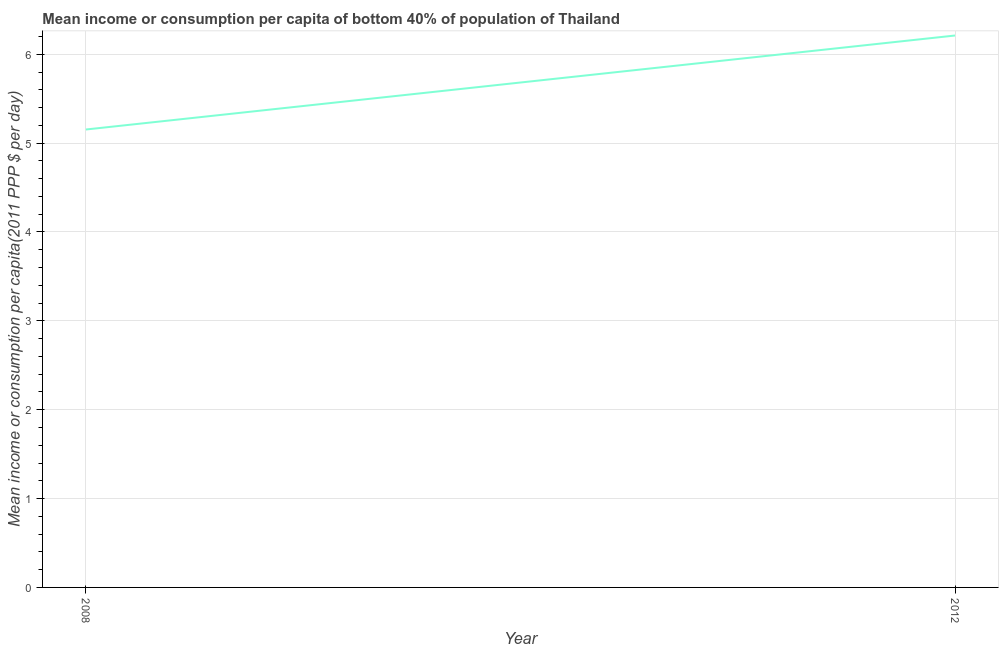What is the mean income or consumption in 2012?
Offer a terse response. 6.21. Across all years, what is the maximum mean income or consumption?
Make the answer very short. 6.21. Across all years, what is the minimum mean income or consumption?
Ensure brevity in your answer.  5.15. In which year was the mean income or consumption maximum?
Give a very brief answer. 2012. In which year was the mean income or consumption minimum?
Offer a terse response. 2008. What is the sum of the mean income or consumption?
Give a very brief answer. 11.36. What is the difference between the mean income or consumption in 2008 and 2012?
Ensure brevity in your answer.  -1.06. What is the average mean income or consumption per year?
Give a very brief answer. 5.68. What is the median mean income or consumption?
Ensure brevity in your answer.  5.68. In how many years, is the mean income or consumption greater than 3.4 $?
Your response must be concise. 2. Do a majority of the years between 2012 and 2008 (inclusive) have mean income or consumption greater than 0.8 $?
Offer a terse response. No. What is the ratio of the mean income or consumption in 2008 to that in 2012?
Your response must be concise. 0.83. In how many years, is the mean income or consumption greater than the average mean income or consumption taken over all years?
Offer a terse response. 1. How many lines are there?
Offer a terse response. 1. How many years are there in the graph?
Ensure brevity in your answer.  2. What is the difference between two consecutive major ticks on the Y-axis?
Ensure brevity in your answer.  1. Does the graph contain grids?
Offer a terse response. Yes. What is the title of the graph?
Offer a terse response. Mean income or consumption per capita of bottom 40% of population of Thailand. What is the label or title of the Y-axis?
Offer a terse response. Mean income or consumption per capita(2011 PPP $ per day). What is the Mean income or consumption per capita(2011 PPP $ per day) of 2008?
Provide a short and direct response. 5.15. What is the Mean income or consumption per capita(2011 PPP $ per day) of 2012?
Give a very brief answer. 6.21. What is the difference between the Mean income or consumption per capita(2011 PPP $ per day) in 2008 and 2012?
Keep it short and to the point. -1.06. What is the ratio of the Mean income or consumption per capita(2011 PPP $ per day) in 2008 to that in 2012?
Your answer should be compact. 0.83. 